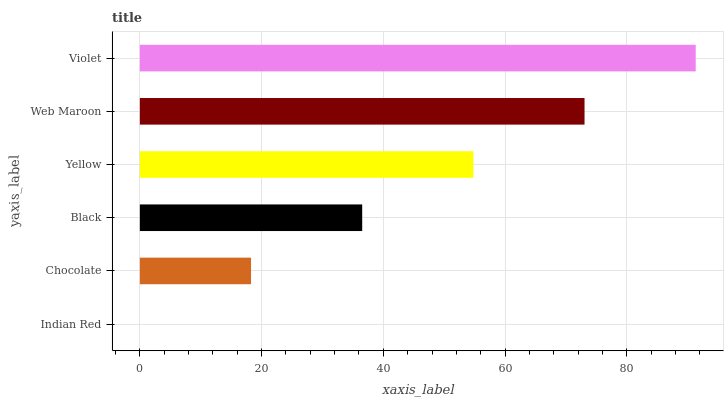Is Indian Red the minimum?
Answer yes or no. Yes. Is Violet the maximum?
Answer yes or no. Yes. Is Chocolate the minimum?
Answer yes or no. No. Is Chocolate the maximum?
Answer yes or no. No. Is Chocolate greater than Indian Red?
Answer yes or no. Yes. Is Indian Red less than Chocolate?
Answer yes or no. Yes. Is Indian Red greater than Chocolate?
Answer yes or no. No. Is Chocolate less than Indian Red?
Answer yes or no. No. Is Yellow the high median?
Answer yes or no. Yes. Is Black the low median?
Answer yes or no. Yes. Is Black the high median?
Answer yes or no. No. Is Violet the low median?
Answer yes or no. No. 